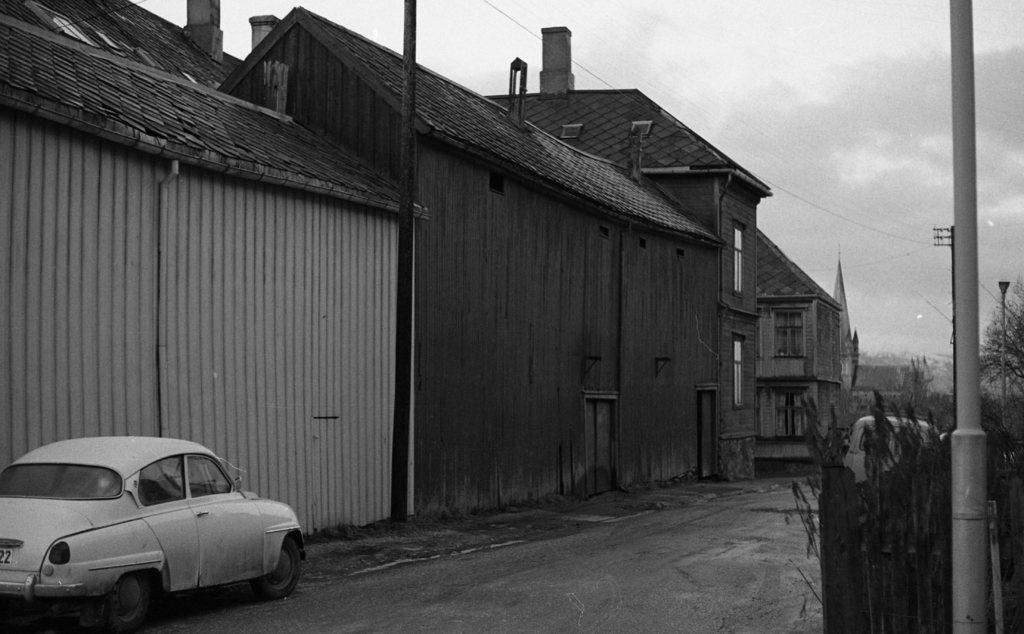Describe this image in one or two sentences. This picture is in black and white. Towards the left, there are houses with chimneys and roof tiles. At the bottom left, there is a car on the road. Towards the right, there is a pole and trees. In the center, there is a road. On the top, there is a sky. 